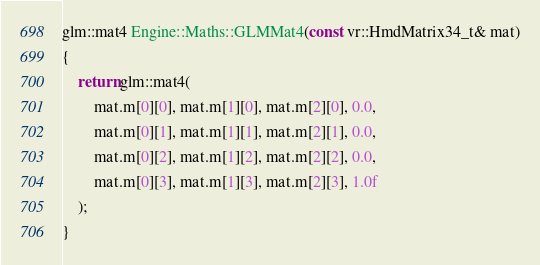Convert code to text. <code><loc_0><loc_0><loc_500><loc_500><_C++_>
glm::mat4 Engine::Maths::GLMMat4(const vr::HmdMatrix34_t& mat)
{
	return glm::mat4(
		mat.m[0][0], mat.m[1][0], mat.m[2][0], 0.0,
		mat.m[0][1], mat.m[1][1], mat.m[2][1], 0.0,
		mat.m[0][2], mat.m[1][2], mat.m[2][2], 0.0,
		mat.m[0][3], mat.m[1][3], mat.m[2][3], 1.0f
	);
}
</code> 